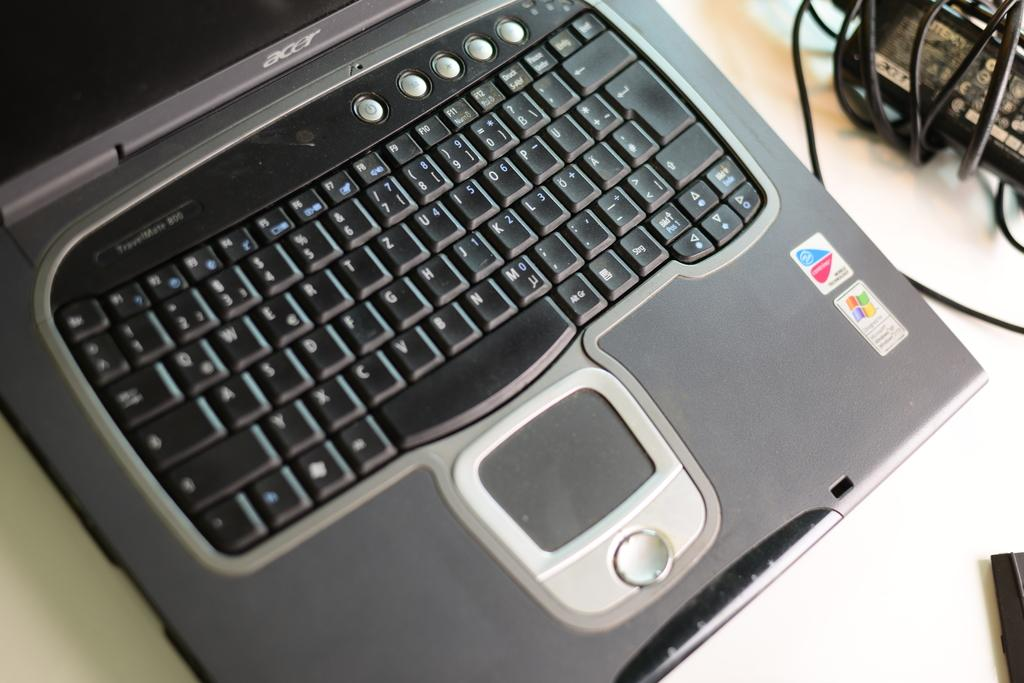Provide a one-sentence caption for the provided image. An open acer laptop showcasing the keyboard and mouse as well as a windows sticker. 